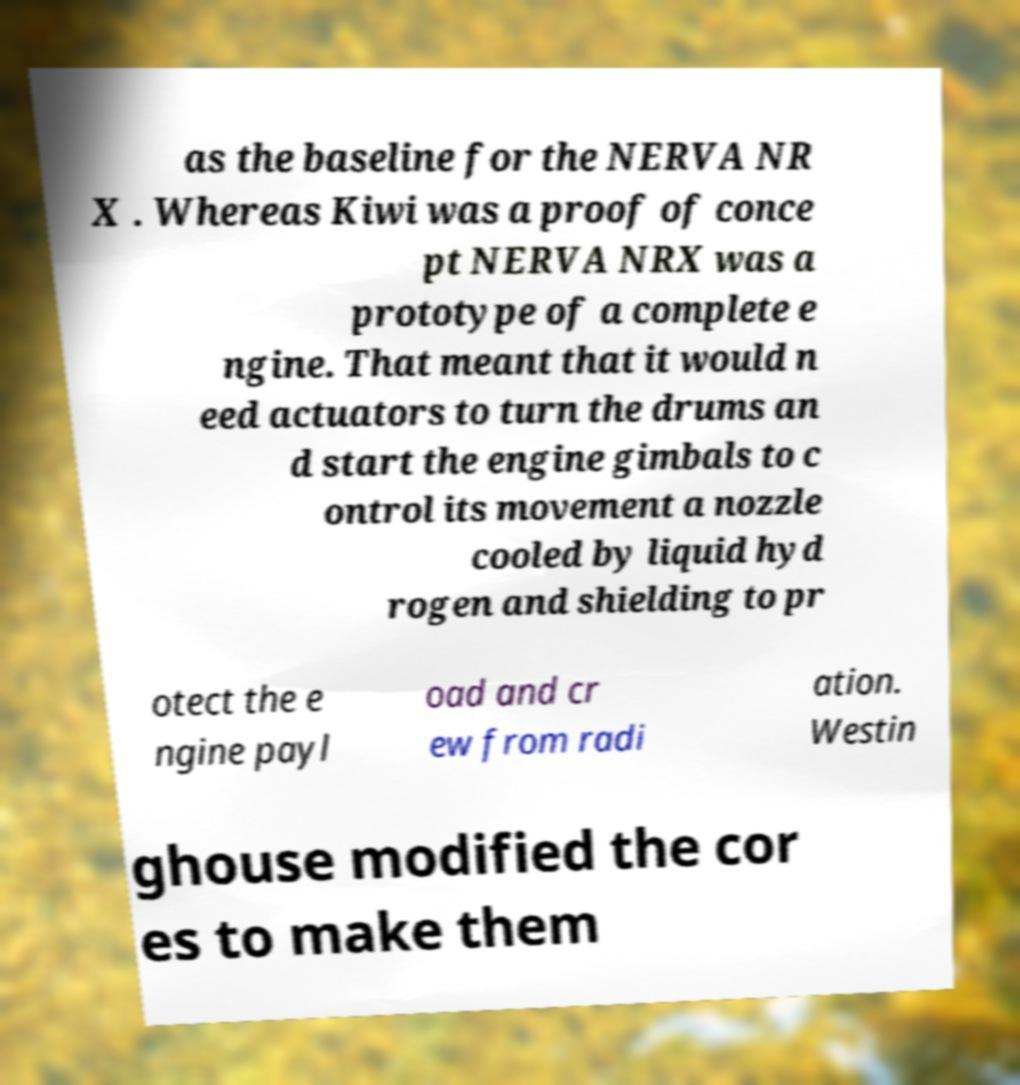Can you read and provide the text displayed in the image?This photo seems to have some interesting text. Can you extract and type it out for me? as the baseline for the NERVA NR X . Whereas Kiwi was a proof of conce pt NERVA NRX was a prototype of a complete e ngine. That meant that it would n eed actuators to turn the drums an d start the engine gimbals to c ontrol its movement a nozzle cooled by liquid hyd rogen and shielding to pr otect the e ngine payl oad and cr ew from radi ation. Westin ghouse modified the cor es to make them 